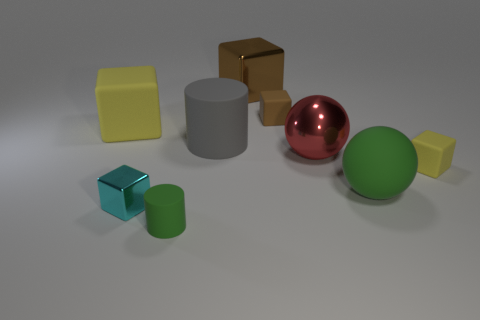Is there any object that seems out of place? In this context, no object seems particularly out of place. Each one contributes to the diversity in shapes, sizes, and textures, presenting a harmonious yet varied collection. 